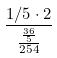Convert formula to latex. <formula><loc_0><loc_0><loc_500><loc_500>\frac { 1 / 5 \cdot 2 } { \frac { \frac { 3 6 } { 5 } } { 2 5 4 } }</formula> 